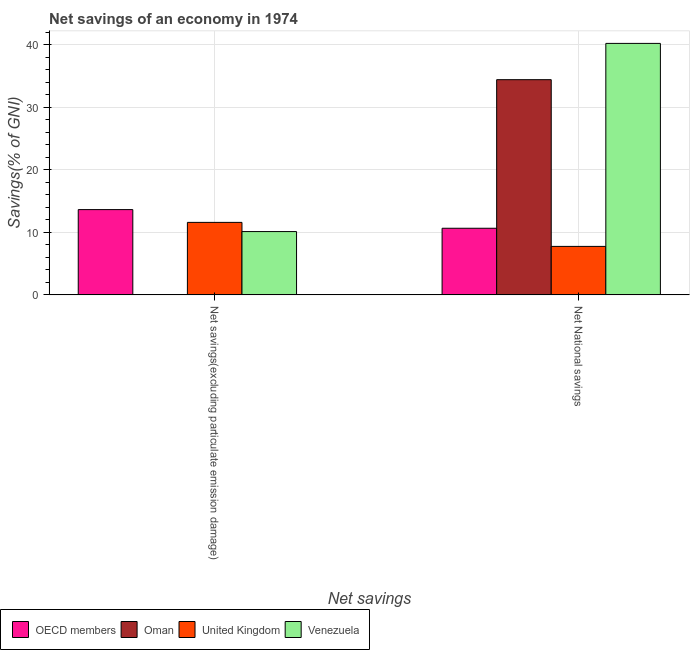How many different coloured bars are there?
Your answer should be compact. 4. Are the number of bars on each tick of the X-axis equal?
Your response must be concise. No. How many bars are there on the 1st tick from the left?
Offer a terse response. 3. What is the label of the 2nd group of bars from the left?
Offer a very short reply. Net National savings. What is the net savings(excluding particulate emission damage) in Oman?
Ensure brevity in your answer.  0. Across all countries, what is the maximum net savings(excluding particulate emission damage)?
Offer a terse response. 13.63. Across all countries, what is the minimum net savings(excluding particulate emission damage)?
Give a very brief answer. 0. In which country was the net savings(excluding particulate emission damage) maximum?
Provide a succinct answer. OECD members. What is the total net savings(excluding particulate emission damage) in the graph?
Offer a very short reply. 35.33. What is the difference between the net national savings in Venezuela and that in Oman?
Keep it short and to the point. 5.8. What is the difference between the net savings(excluding particulate emission damage) in Venezuela and the net national savings in Oman?
Your response must be concise. -24.27. What is the average net savings(excluding particulate emission damage) per country?
Make the answer very short. 8.83. What is the difference between the net national savings and net savings(excluding particulate emission damage) in Venezuela?
Make the answer very short. 30.07. What is the ratio of the net savings(excluding particulate emission damage) in United Kingdom to that in Venezuela?
Your response must be concise. 1.15. How many bars are there?
Ensure brevity in your answer.  7. Are all the bars in the graph horizontal?
Provide a short and direct response. No. How many countries are there in the graph?
Ensure brevity in your answer.  4. What is the difference between two consecutive major ticks on the Y-axis?
Your response must be concise. 10. Where does the legend appear in the graph?
Your answer should be compact. Bottom left. How many legend labels are there?
Your answer should be very brief. 4. What is the title of the graph?
Your answer should be compact. Net savings of an economy in 1974. What is the label or title of the X-axis?
Keep it short and to the point. Net savings. What is the label or title of the Y-axis?
Your answer should be very brief. Savings(% of GNI). What is the Savings(% of GNI) of OECD members in Net savings(excluding particulate emission damage)?
Make the answer very short. 13.63. What is the Savings(% of GNI) of Oman in Net savings(excluding particulate emission damage)?
Ensure brevity in your answer.  0. What is the Savings(% of GNI) in United Kingdom in Net savings(excluding particulate emission damage)?
Ensure brevity in your answer.  11.59. What is the Savings(% of GNI) in Venezuela in Net savings(excluding particulate emission damage)?
Provide a short and direct response. 10.12. What is the Savings(% of GNI) of OECD members in Net National savings?
Offer a terse response. 10.65. What is the Savings(% of GNI) of Oman in Net National savings?
Offer a terse response. 34.39. What is the Savings(% of GNI) in United Kingdom in Net National savings?
Provide a succinct answer. 7.75. What is the Savings(% of GNI) in Venezuela in Net National savings?
Provide a succinct answer. 40.19. Across all Net savings, what is the maximum Savings(% of GNI) of OECD members?
Offer a very short reply. 13.63. Across all Net savings, what is the maximum Savings(% of GNI) of Oman?
Your answer should be very brief. 34.39. Across all Net savings, what is the maximum Savings(% of GNI) of United Kingdom?
Give a very brief answer. 11.59. Across all Net savings, what is the maximum Savings(% of GNI) in Venezuela?
Your response must be concise. 40.19. Across all Net savings, what is the minimum Savings(% of GNI) of OECD members?
Your answer should be compact. 10.65. Across all Net savings, what is the minimum Savings(% of GNI) of Oman?
Your response must be concise. 0. Across all Net savings, what is the minimum Savings(% of GNI) of United Kingdom?
Provide a short and direct response. 7.75. Across all Net savings, what is the minimum Savings(% of GNI) of Venezuela?
Provide a short and direct response. 10.12. What is the total Savings(% of GNI) of OECD members in the graph?
Your answer should be compact. 24.28. What is the total Savings(% of GNI) in Oman in the graph?
Your answer should be compact. 34.39. What is the total Savings(% of GNI) in United Kingdom in the graph?
Ensure brevity in your answer.  19.33. What is the total Savings(% of GNI) of Venezuela in the graph?
Your response must be concise. 50.3. What is the difference between the Savings(% of GNI) in OECD members in Net savings(excluding particulate emission damage) and that in Net National savings?
Your response must be concise. 2.98. What is the difference between the Savings(% of GNI) in United Kingdom in Net savings(excluding particulate emission damage) and that in Net National savings?
Your response must be concise. 3.84. What is the difference between the Savings(% of GNI) of Venezuela in Net savings(excluding particulate emission damage) and that in Net National savings?
Keep it short and to the point. -30.07. What is the difference between the Savings(% of GNI) of OECD members in Net savings(excluding particulate emission damage) and the Savings(% of GNI) of Oman in Net National savings?
Ensure brevity in your answer.  -20.76. What is the difference between the Savings(% of GNI) of OECD members in Net savings(excluding particulate emission damage) and the Savings(% of GNI) of United Kingdom in Net National savings?
Offer a terse response. 5.88. What is the difference between the Savings(% of GNI) of OECD members in Net savings(excluding particulate emission damage) and the Savings(% of GNI) of Venezuela in Net National savings?
Offer a terse response. -26.56. What is the difference between the Savings(% of GNI) of United Kingdom in Net savings(excluding particulate emission damage) and the Savings(% of GNI) of Venezuela in Net National savings?
Ensure brevity in your answer.  -28.6. What is the average Savings(% of GNI) of OECD members per Net savings?
Your answer should be very brief. 12.14. What is the average Savings(% of GNI) in Oman per Net savings?
Your answer should be compact. 17.2. What is the average Savings(% of GNI) in United Kingdom per Net savings?
Keep it short and to the point. 9.67. What is the average Savings(% of GNI) of Venezuela per Net savings?
Make the answer very short. 25.15. What is the difference between the Savings(% of GNI) in OECD members and Savings(% of GNI) in United Kingdom in Net savings(excluding particulate emission damage)?
Your answer should be very brief. 2.04. What is the difference between the Savings(% of GNI) in OECD members and Savings(% of GNI) in Venezuela in Net savings(excluding particulate emission damage)?
Offer a terse response. 3.51. What is the difference between the Savings(% of GNI) in United Kingdom and Savings(% of GNI) in Venezuela in Net savings(excluding particulate emission damage)?
Ensure brevity in your answer.  1.47. What is the difference between the Savings(% of GNI) of OECD members and Savings(% of GNI) of Oman in Net National savings?
Offer a very short reply. -23.74. What is the difference between the Savings(% of GNI) in OECD members and Savings(% of GNI) in United Kingdom in Net National savings?
Offer a terse response. 2.9. What is the difference between the Savings(% of GNI) in OECD members and Savings(% of GNI) in Venezuela in Net National savings?
Provide a succinct answer. -29.54. What is the difference between the Savings(% of GNI) in Oman and Savings(% of GNI) in United Kingdom in Net National savings?
Your answer should be very brief. 26.64. What is the difference between the Savings(% of GNI) in Oman and Savings(% of GNI) in Venezuela in Net National savings?
Offer a terse response. -5.8. What is the difference between the Savings(% of GNI) in United Kingdom and Savings(% of GNI) in Venezuela in Net National savings?
Offer a terse response. -32.44. What is the ratio of the Savings(% of GNI) of OECD members in Net savings(excluding particulate emission damage) to that in Net National savings?
Your answer should be compact. 1.28. What is the ratio of the Savings(% of GNI) in United Kingdom in Net savings(excluding particulate emission damage) to that in Net National savings?
Your answer should be very brief. 1.5. What is the ratio of the Savings(% of GNI) in Venezuela in Net savings(excluding particulate emission damage) to that in Net National savings?
Your answer should be compact. 0.25. What is the difference between the highest and the second highest Savings(% of GNI) in OECD members?
Offer a terse response. 2.98. What is the difference between the highest and the second highest Savings(% of GNI) of United Kingdom?
Make the answer very short. 3.84. What is the difference between the highest and the second highest Savings(% of GNI) of Venezuela?
Offer a very short reply. 30.07. What is the difference between the highest and the lowest Savings(% of GNI) of OECD members?
Make the answer very short. 2.98. What is the difference between the highest and the lowest Savings(% of GNI) in Oman?
Your answer should be compact. 34.39. What is the difference between the highest and the lowest Savings(% of GNI) of United Kingdom?
Give a very brief answer. 3.84. What is the difference between the highest and the lowest Savings(% of GNI) of Venezuela?
Ensure brevity in your answer.  30.07. 